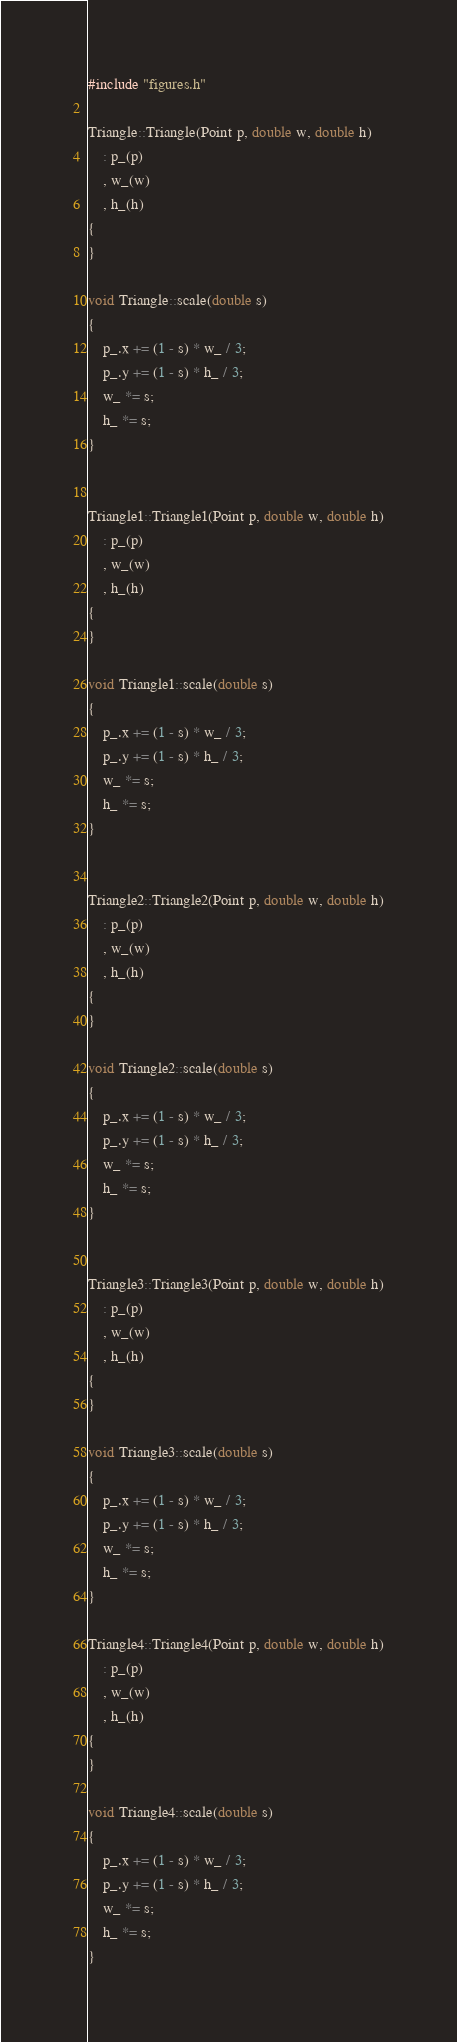<code> <loc_0><loc_0><loc_500><loc_500><_C++_>#include "figures.h"

Triangle::Triangle(Point p, double w, double h)
	: p_(p)
	, w_(w)
	, h_(h)
{
}

void Triangle::scale(double s)
{
	p_.x += (1 - s) * w_ / 3;
	p_.y += (1 - s) * h_ / 3;
	w_ *= s;
	h_ *= s;
}


Triangle1::Triangle1(Point p, double w, double h)
	: p_(p)
	, w_(w)
	, h_(h)
{
}

void Triangle1::scale(double s)
{
	p_.x += (1 - s) * w_ / 3;
	p_.y += (1 - s) * h_ / 3;
	w_ *= s;
	h_ *= s;
}


Triangle2::Triangle2(Point p, double w, double h)
	: p_(p)
	, w_(w)
	, h_(h)
{
}

void Triangle2::scale(double s)
{
	p_.x += (1 - s) * w_ / 3;
	p_.y += (1 - s) * h_ / 3;
	w_ *= s;
	h_ *= s;
}


Triangle3::Triangle3(Point p, double w, double h)
	: p_(p)
	, w_(w)
	, h_(h)
{
}

void Triangle3::scale(double s)
{
	p_.x += (1 - s) * w_ / 3;
	p_.y += (1 - s) * h_ / 3;
	w_ *= s;
	h_ *= s;
}

Triangle4::Triangle4(Point p, double w, double h)
	: p_(p)
	, w_(w)
	, h_(h)
{
}

void Triangle4::scale(double s)
{
	p_.x += (1 - s) * w_ / 3;
	p_.y += (1 - s) * h_ / 3;
	w_ *= s;
	h_ *= s;
}
</code> 